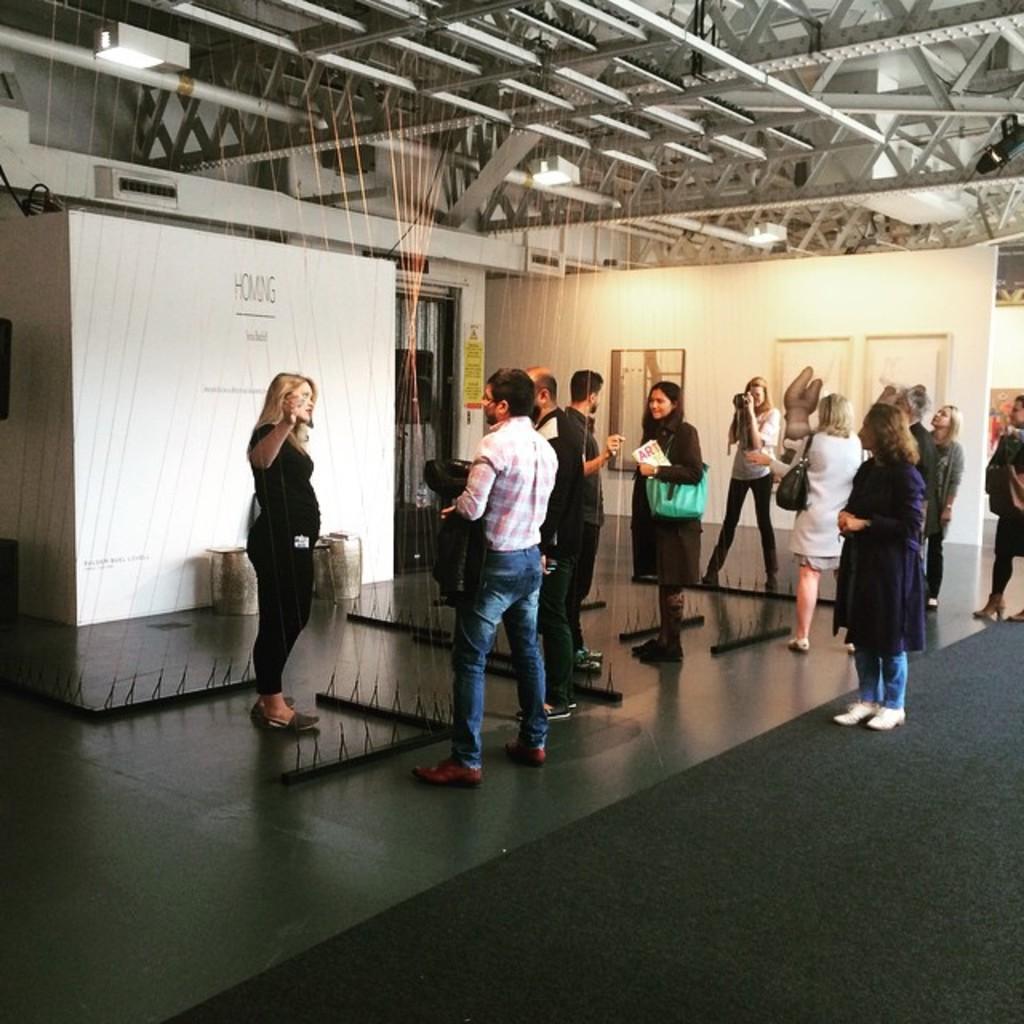In one or two sentences, can you explain what this image depicts? In this image I can see group of people standing. In the background I can see the board and few lights and I can also see few poles. 